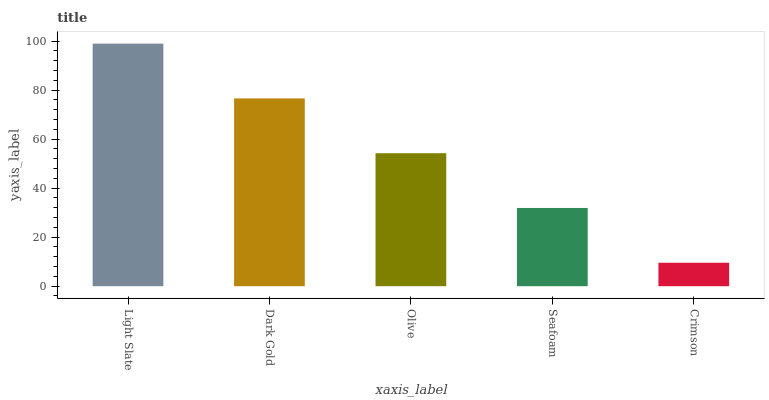Is Crimson the minimum?
Answer yes or no. Yes. Is Light Slate the maximum?
Answer yes or no. Yes. Is Dark Gold the minimum?
Answer yes or no. No. Is Dark Gold the maximum?
Answer yes or no. No. Is Light Slate greater than Dark Gold?
Answer yes or no. Yes. Is Dark Gold less than Light Slate?
Answer yes or no. Yes. Is Dark Gold greater than Light Slate?
Answer yes or no. No. Is Light Slate less than Dark Gold?
Answer yes or no. No. Is Olive the high median?
Answer yes or no. Yes. Is Olive the low median?
Answer yes or no. Yes. Is Crimson the high median?
Answer yes or no. No. Is Light Slate the low median?
Answer yes or no. No. 